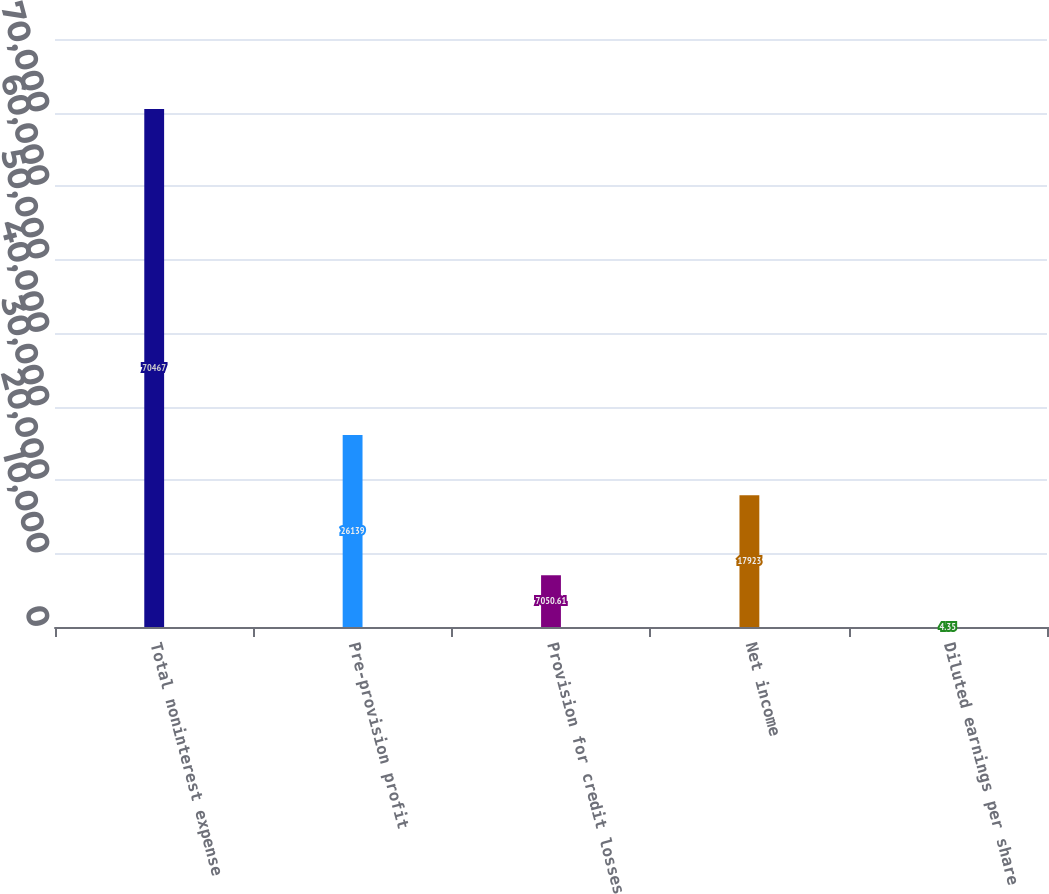Convert chart to OTSL. <chart><loc_0><loc_0><loc_500><loc_500><bar_chart><fcel>Total noninterest expense<fcel>Pre-provision profit<fcel>Provision for credit losses<fcel>Net income<fcel>Diluted earnings per share<nl><fcel>70467<fcel>26139<fcel>7050.61<fcel>17923<fcel>4.35<nl></chart> 